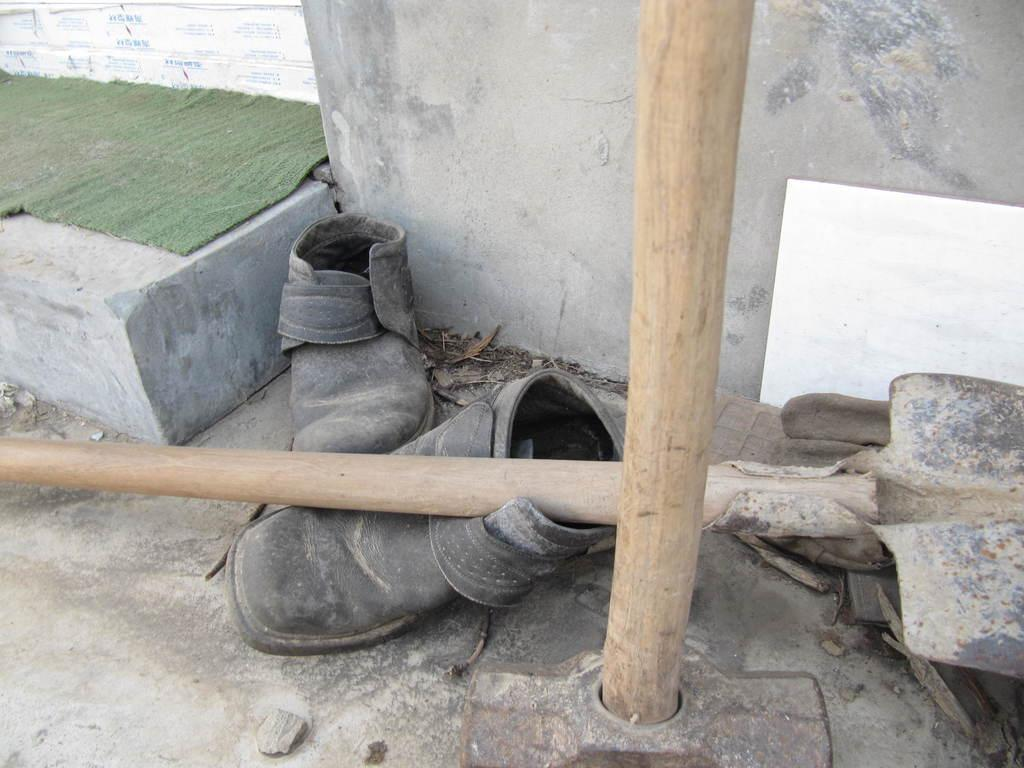What objects can be seen in the image? There are shoes and bamboos in the image. What is the flooring made of in the image? There is a green carpet on a concrete brick in the image. Is there any wall decoration visible in the image? Yes, there is a poster near a wall in the image. What type of brass instrument is being played in the image? There is no brass instrument or any indication of music being played in the image. 